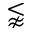Convert formula to latex. <formula><loc_0><loc_0><loc_500><loc_500>\lnapprox</formula> 